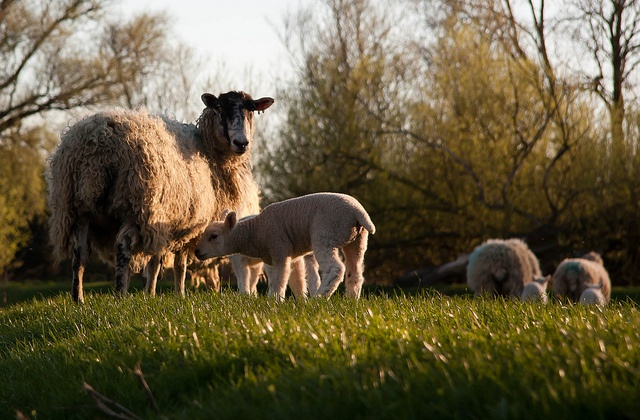Describe the objects in this image and their specific colors. I can see sheep in darkgray, black, and tan tones, sheep in darkgray, black, gray, and maroon tones, sheep in darkgray, black, and gray tones, sheep in darkgray, black, and gray tones, and sheep in darkgray, gray, black, and tan tones in this image. 